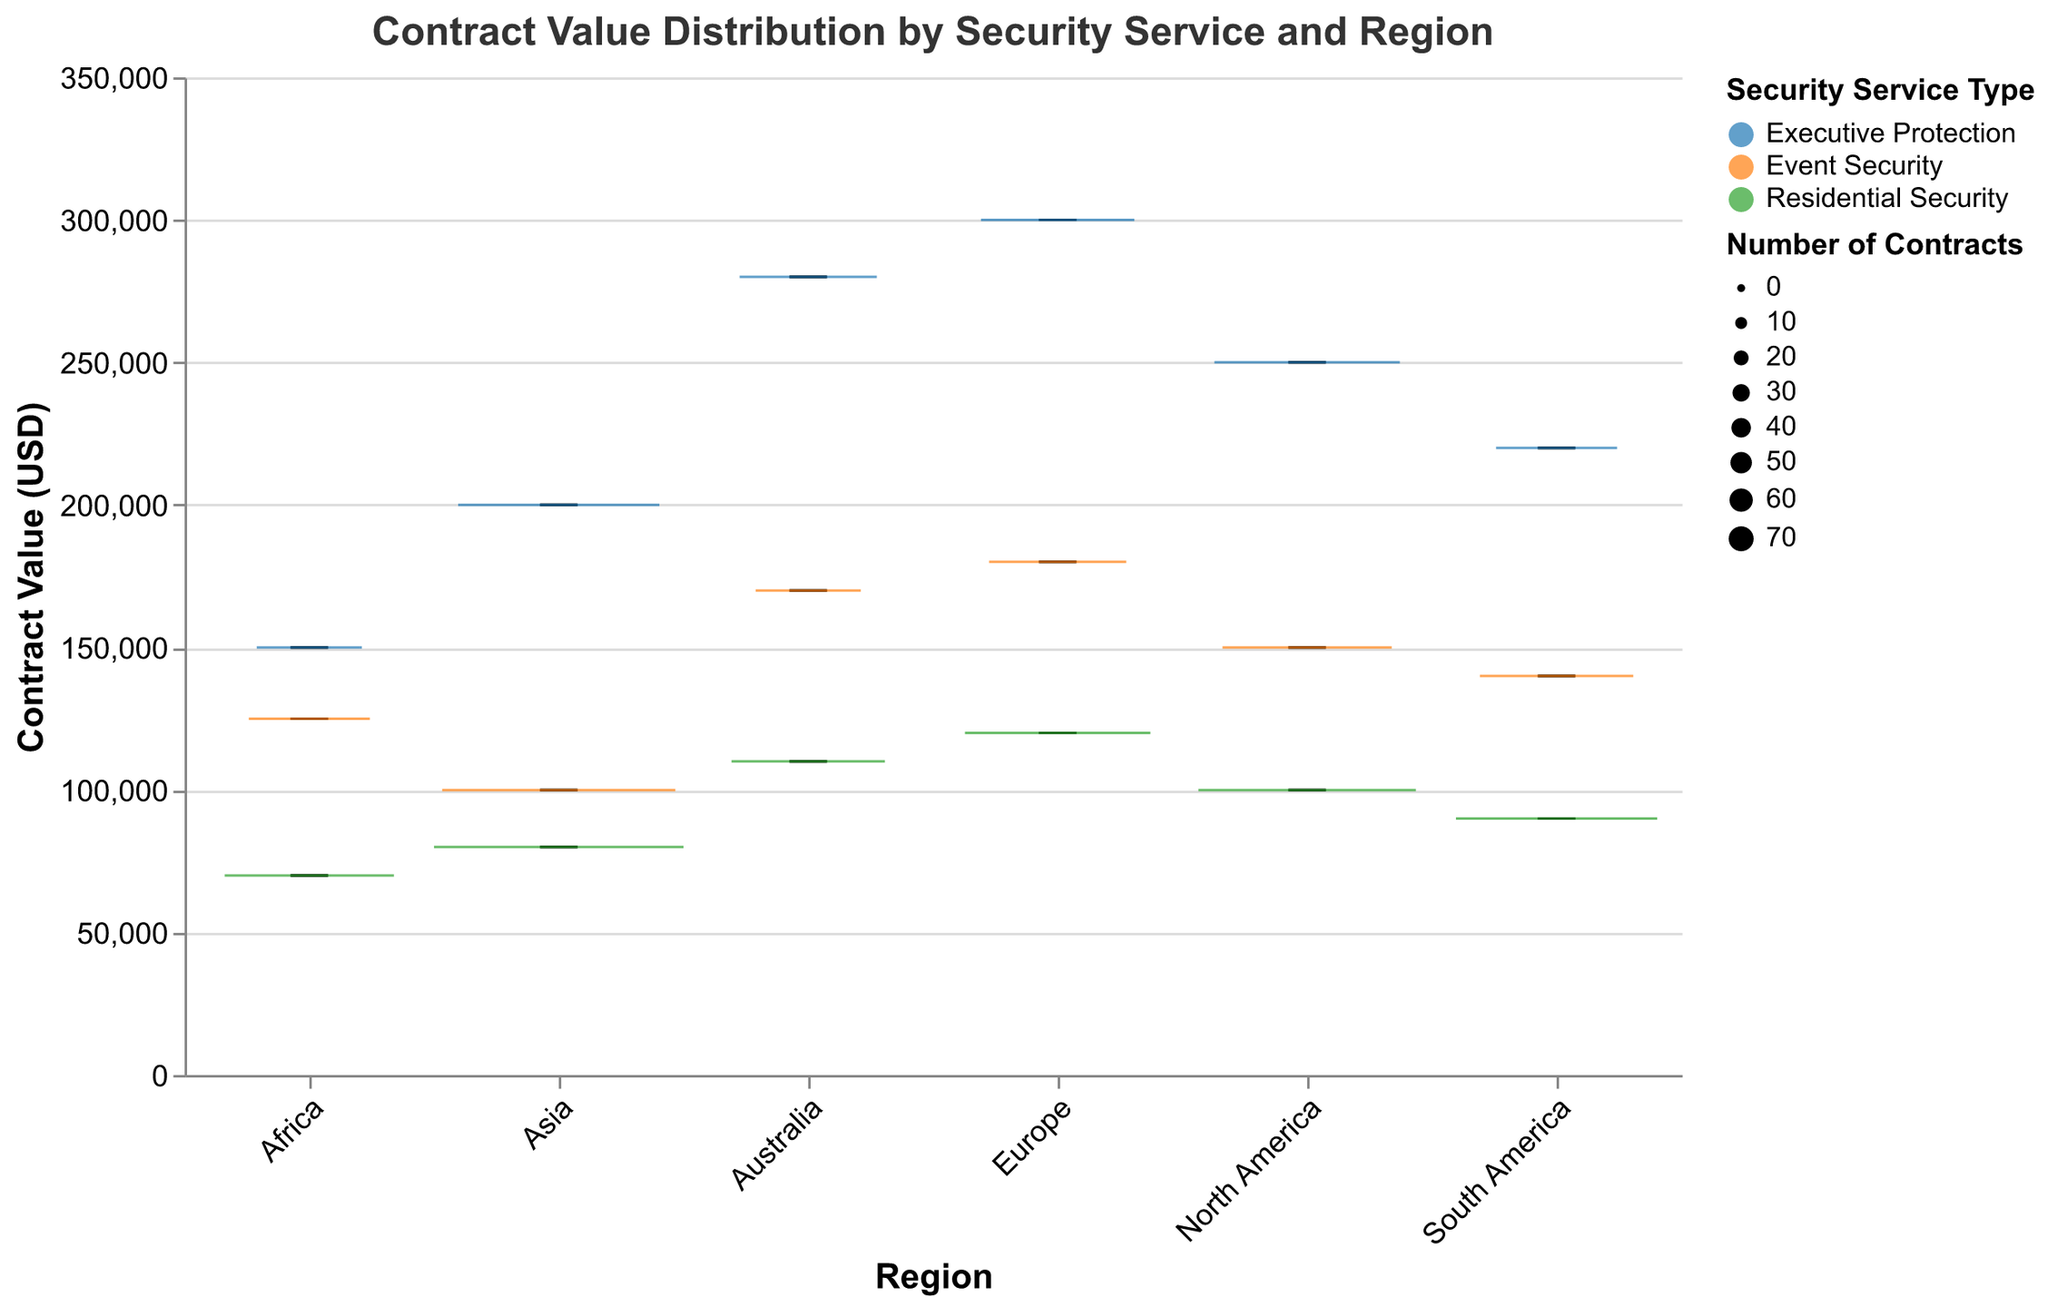What is the title of the plot? The title is shown at the top of the plot in a larger font. It reads "Contract Value Distribution by Security Service and Region".
Answer: Contract Value Distribution by Security Service and Region Which region has the highest median contract value for Executive Protection? By checking the box plot for Executive Protection across different regions, the median line for Europe is the highest among all regions.
Answer: Europe How many types of security services are compared in the plot? The color legend indicates that there are three types: Executive Protection, Event Security, and Residential Security.
Answer: Three Which service type has the widest contract value range in Asia? The width of the box plot (the length of the whiskers) for Event Security in Asia is the largest.
Answer: Event Security What is the median contract value for Residential Security in North America? For Residential Security in North America, the line inside the box plot represents the median, which is at 100,000 USD.
Answer: 100,000 USD Which region has the smallest number of contracts for any service type, and what is that service type? By looking at the size of the boxes (width), Africa for Executive Protection has the smallest width, indicating the smallest number of contracts (25).
Answer: Africa, Executive Protection What is the interquartile range (IQR) for Event Security in Europe? The IQR can be observed from the distance between the bottom and top of the box for Event Security in Europe. The bottom is at 130,000 USD, and the top is at 180,000 USD, so the IQR is 180,000 - 130,000.
Answer: 50,000 USD Which combination of region and service type has the highest outlier contract values? The outliers are marked in red. Executive Protection in Australia shows the highest outlier above the main whisker, at close to 280,000 USD.
Answer: Australia, Executive Protection Which region has the largest number of contracts for Residential Security? Box width indicates the number of contracts. Asia has the widest box for Residential Security, indicating the largest number of contracts (70).
Answer: Asia 